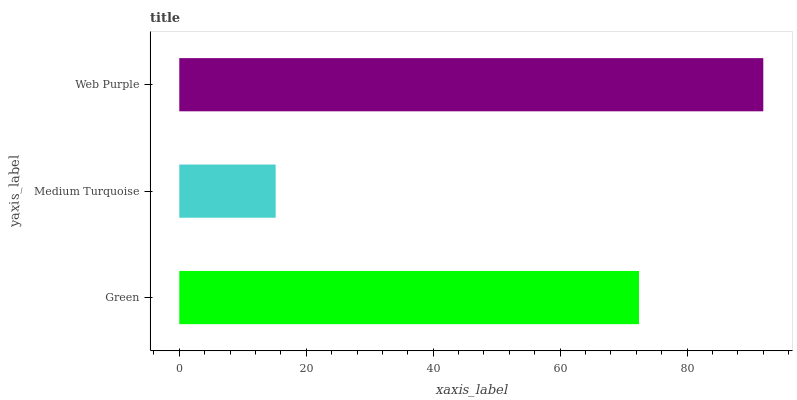Is Medium Turquoise the minimum?
Answer yes or no. Yes. Is Web Purple the maximum?
Answer yes or no. Yes. Is Web Purple the minimum?
Answer yes or no. No. Is Medium Turquoise the maximum?
Answer yes or no. No. Is Web Purple greater than Medium Turquoise?
Answer yes or no. Yes. Is Medium Turquoise less than Web Purple?
Answer yes or no. Yes. Is Medium Turquoise greater than Web Purple?
Answer yes or no. No. Is Web Purple less than Medium Turquoise?
Answer yes or no. No. Is Green the high median?
Answer yes or no. Yes. Is Green the low median?
Answer yes or no. Yes. Is Medium Turquoise the high median?
Answer yes or no. No. Is Medium Turquoise the low median?
Answer yes or no. No. 